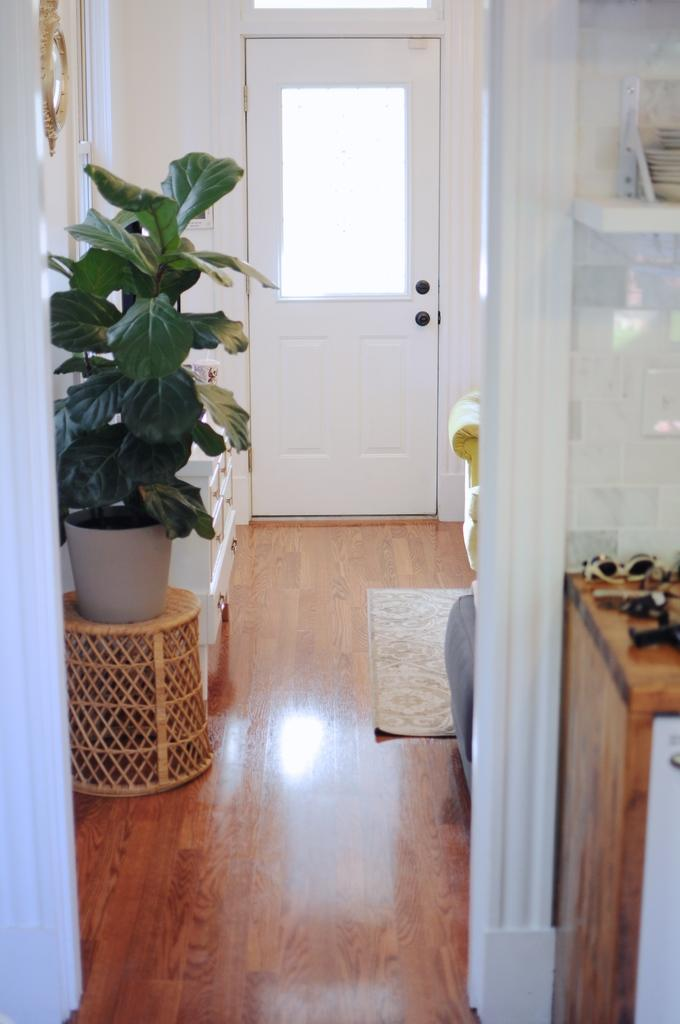What type of space is depicted in the image? There is a room in the picture. What features of the room can be identified? The room has a door, walls, and a wooden floor. Are there any living elements in the room? Yes, there is a plant in the room. What is on the floor of the room? There is a mat on the floor. What can be found on the table in the room? There are objects on the table. What type of wool is used to make the cap on the table in the image? There is no cap present on the table in the image. Can you describe the air quality in the room based on the image? The image does not provide any information about the air quality in the room. 